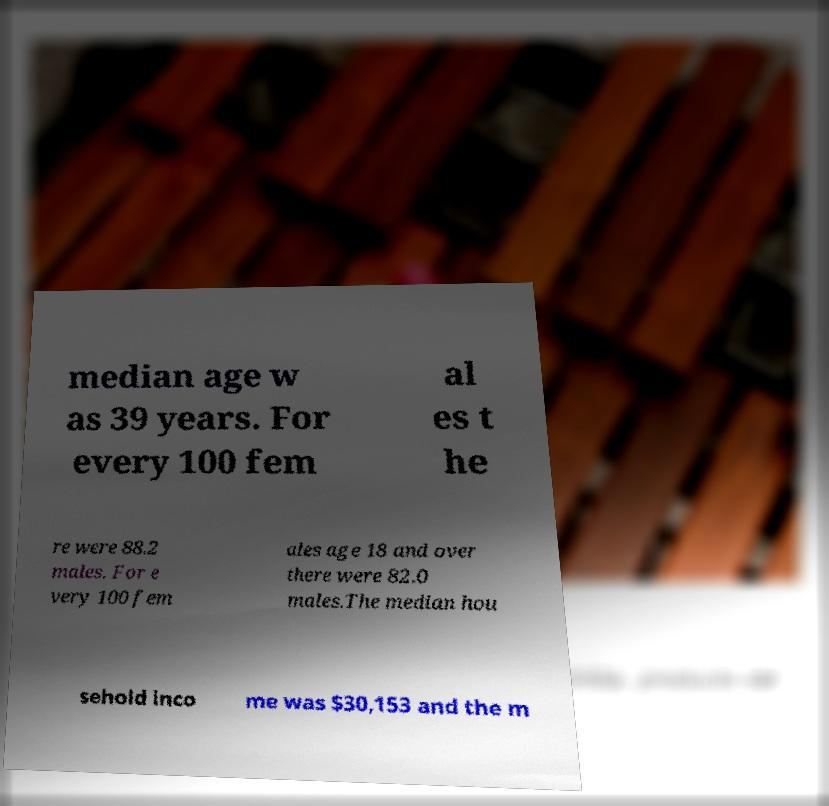What messages or text are displayed in this image? I need them in a readable, typed format. median age w as 39 years. For every 100 fem al es t he re were 88.2 males. For e very 100 fem ales age 18 and over there were 82.0 males.The median hou sehold inco me was $30,153 and the m 